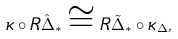<formula> <loc_0><loc_0><loc_500><loc_500>\kappa \circ R \hat { \Delta } _ { * } \cong R \tilde { \Delta } _ { * } \circ \kappa _ { \Delta } ,</formula> 